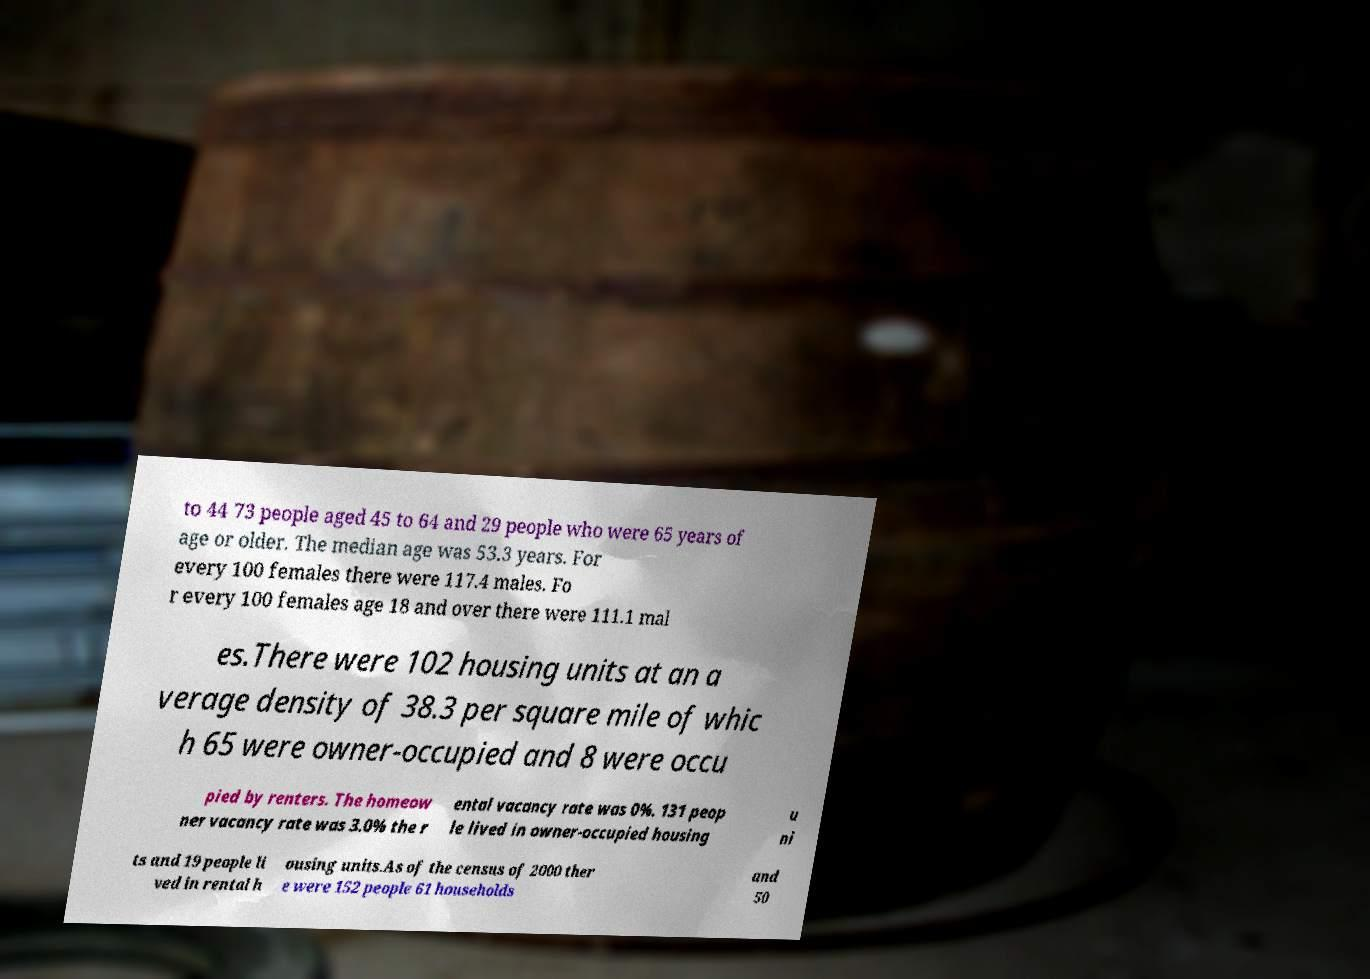Can you read and provide the text displayed in the image?This photo seems to have some interesting text. Can you extract and type it out for me? to 44 73 people aged 45 to 64 and 29 people who were 65 years of age or older. The median age was 53.3 years. For every 100 females there were 117.4 males. Fo r every 100 females age 18 and over there were 111.1 mal es.There were 102 housing units at an a verage density of 38.3 per square mile of whic h 65 were owner-occupied and 8 were occu pied by renters. The homeow ner vacancy rate was 3.0% the r ental vacancy rate was 0%. 131 peop le lived in owner-occupied housing u ni ts and 19 people li ved in rental h ousing units.As of the census of 2000 ther e were 152 people 61 households and 50 